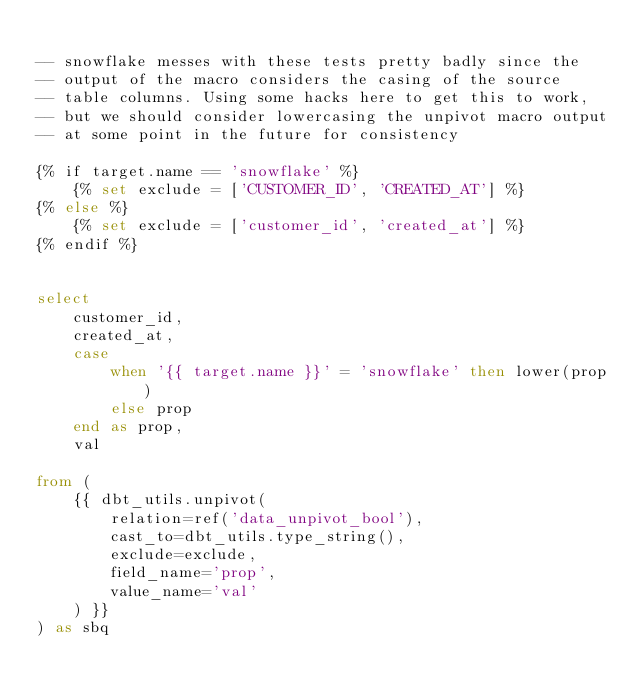Convert code to text. <code><loc_0><loc_0><loc_500><loc_500><_SQL_>
-- snowflake messes with these tests pretty badly since the
-- output of the macro considers the casing of the source
-- table columns. Using some hacks here to get this to work,
-- but we should consider lowercasing the unpivot macro output
-- at some point in the future for consistency

{% if target.name == 'snowflake' %}
    {% set exclude = ['CUSTOMER_ID', 'CREATED_AT'] %}
{% else %}
    {% set exclude = ['customer_id', 'created_at'] %}
{% endif %}


select
    customer_id,
    created_at,
    case
        when '{{ target.name }}' = 'snowflake' then lower(prop)
        else prop
    end as prop,
    val

from (
    {{ dbt_utils.unpivot(
        relation=ref('data_unpivot_bool'),
        cast_to=dbt_utils.type_string(),
        exclude=exclude,
        field_name='prop',
        value_name='val'
    ) }}
) as sbq
</code> 